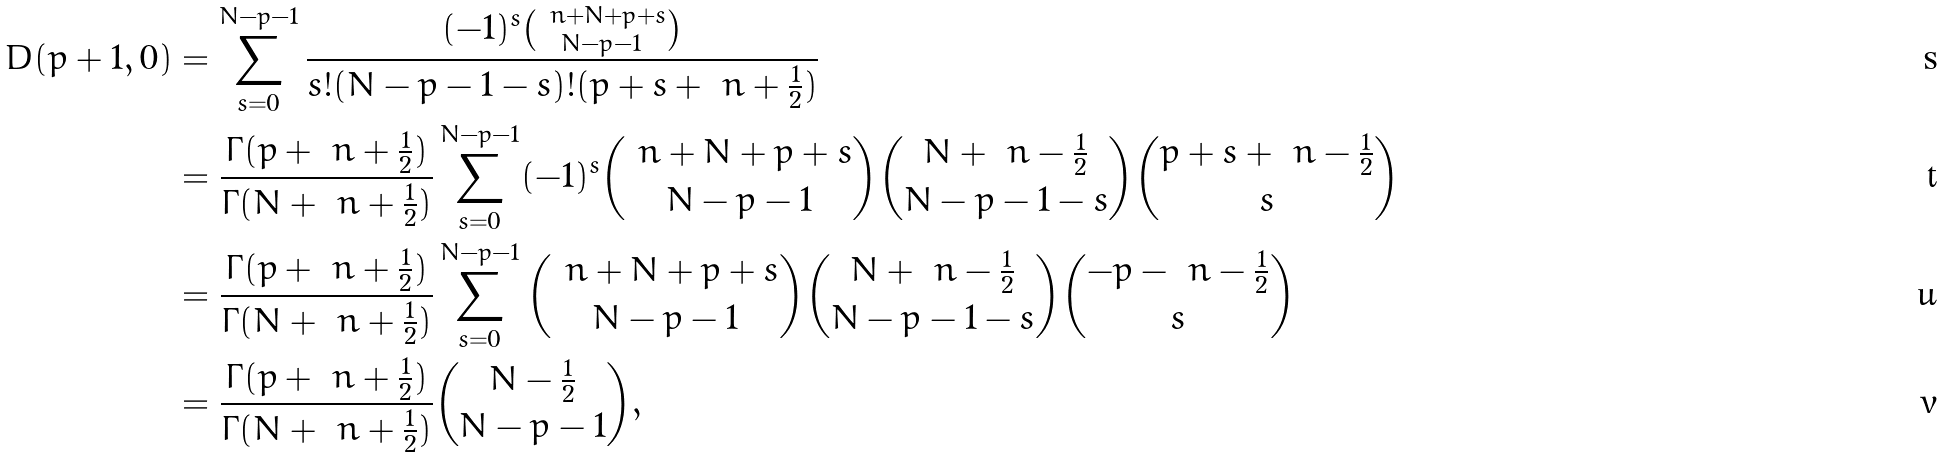Convert formula to latex. <formula><loc_0><loc_0><loc_500><loc_500>D ( p + 1 , 0 ) & = \sum _ { s = 0 } ^ { N - p - 1 } \frac { ( - 1 ) ^ { s } { \ n + N + p + s \choose N - p - 1 } } { s ! ( N - p - 1 - s ) ! ( p + s + \ n + \frac { 1 } { 2 } ) } \\ & = \frac { \Gamma ( p + \ n + \frac { 1 } { 2 } ) } { \Gamma ( N + \ n + \frac { 1 } { 2 } ) } \sum _ { s = 0 } ^ { N - p - 1 } ( - 1 ) ^ { s } { \ n + N + p + s \choose N - p - 1 } { N + \ n - \frac { 1 } { 2 } \choose N - p - 1 - s } { p + s + \ n - \frac { 1 } { 2 } \choose s } \\ & = \frac { \Gamma ( p + \ n + \frac { 1 } { 2 } ) } { \Gamma ( N + \ n + \frac { 1 } { 2 } ) } \sum _ { s = 0 } ^ { N - p - 1 } { \ n + N + p + s \choose N - p - 1 } { N + \ n - \frac { 1 } { 2 } \choose N - p - 1 - s } { - p - \ n - \frac { 1 } { 2 } \choose s } \\ & = \frac { \Gamma ( p + \ n + \frac { 1 } { 2 } ) } { \Gamma ( N + \ n + \frac { 1 } { 2 } ) } { N - \frac { 1 } { 2 } \choose N - p - 1 } ,</formula> 